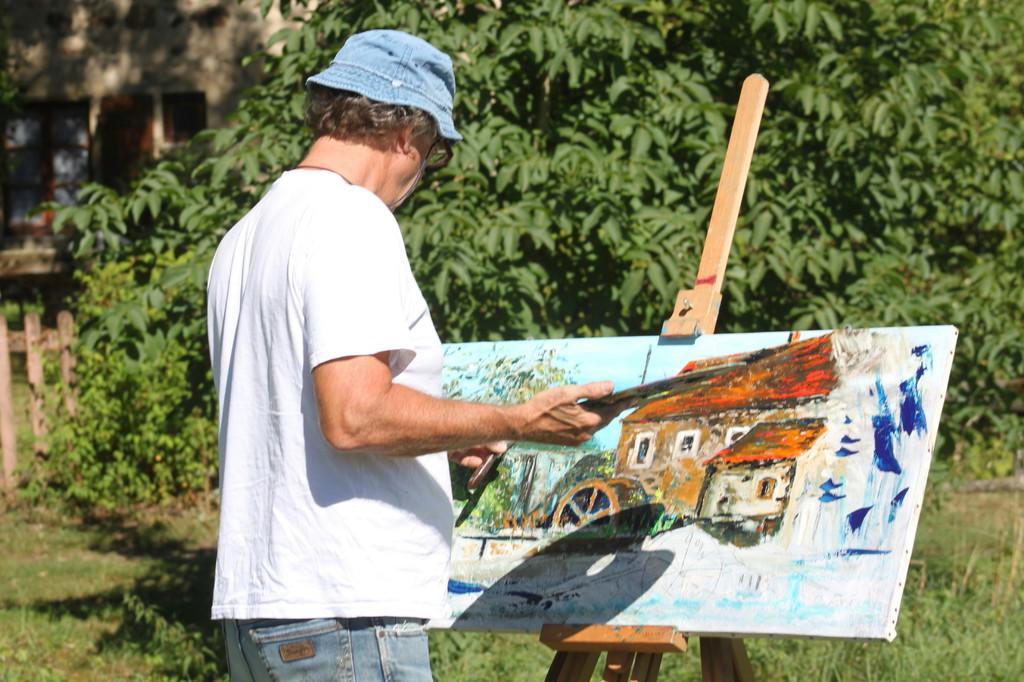In one or two sentences, can you explain what this image depicts? In this image there is a man standing in the garden and painting on the sheet, behind him there are trees and building. 